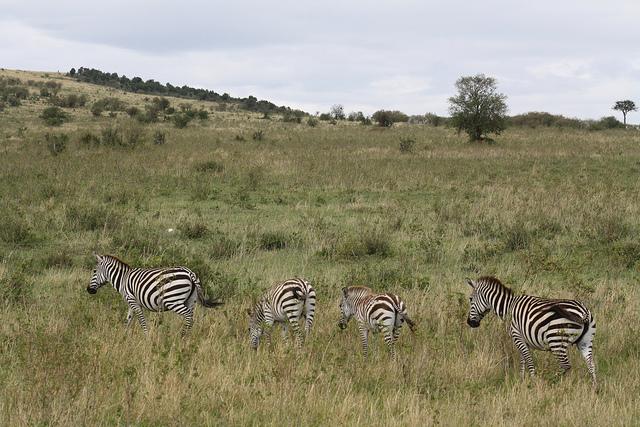What animals are in the field?
Keep it brief. Zebras. How many zebras are in the photo?
Concise answer only. 4. Is this a tiger?
Quick response, please. No. 